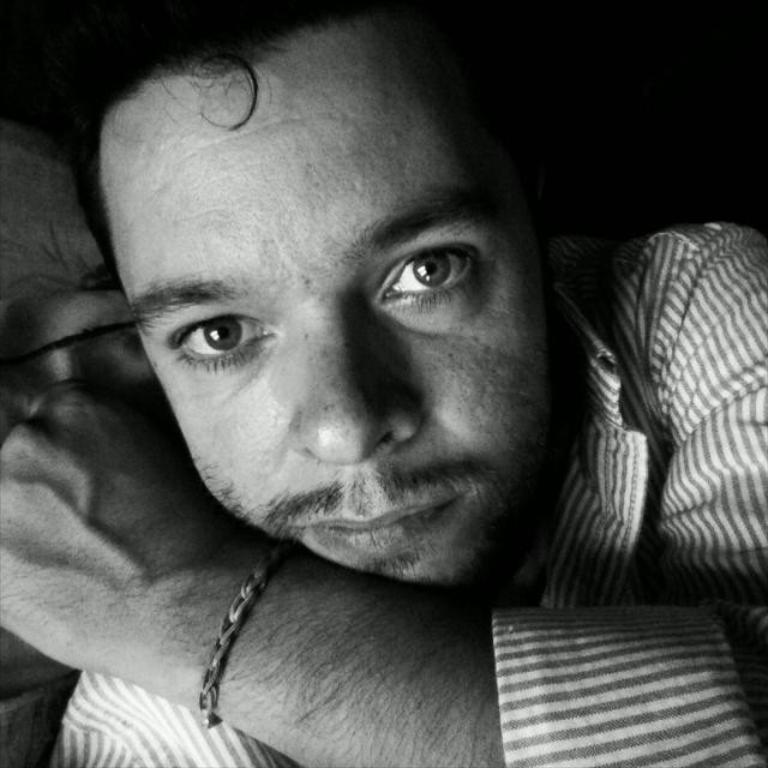How would you summarize this image in a sentence or two? In this image there is a person. 